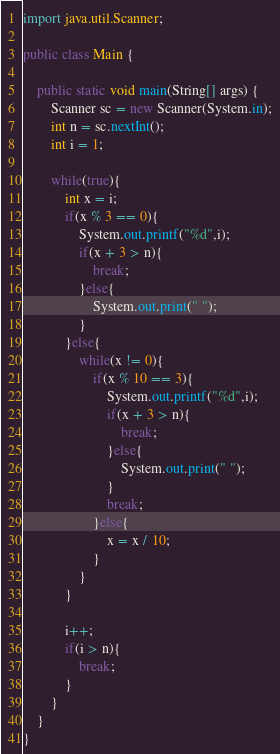Convert code to text. <code><loc_0><loc_0><loc_500><loc_500><_Java_>
import java.util.Scanner;

public class Main {

	public static void main(String[] args) {
		Scanner sc = new Scanner(System.in);
		int n = sc.nextInt();
		int i = 1;

		while(true){
			int x = i;
			if(x % 3 == 0){
				System.out.printf("%d",i);
				if(x + 3 > n){
					break;
				}else{
					System.out.print(" ");
				}
			}else{
				while(x != 0){
					if(x % 10 == 3){
						System.out.printf("%d",i);
						if(x + 3 > n){
							break;
						}else{
							System.out.print(" ");
						}
						break;
					}else{
						x = x / 10;
					}
				}
			}

			i++;
			if(i > n){
				break;
			}
		}
	}
}</code> 